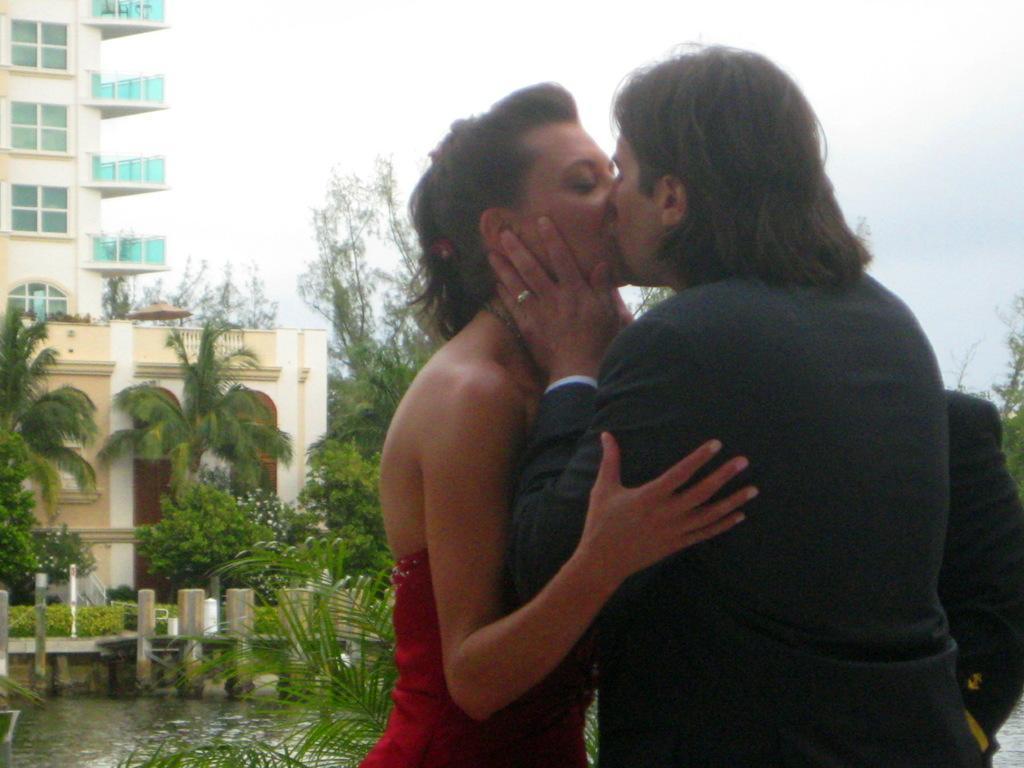Describe this image in one or two sentences. In the foreground of this image, there is a woman and a man kissing each other and it seems like there is another person behind them. In the background, there is water, greenery, buildings and the sky. 